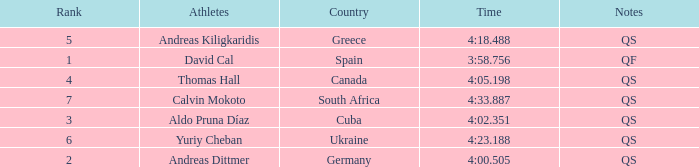What is Calvin Mokoto's average rank? 7.0. 